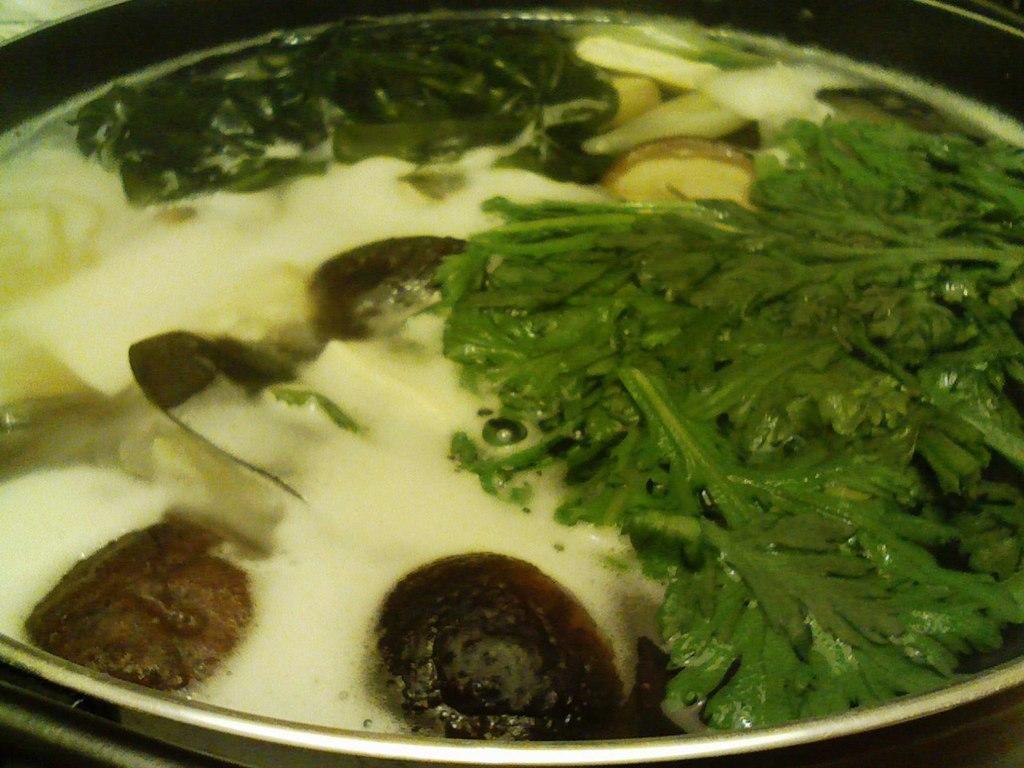Can you describe this image briefly? Here we can see vegetable leaves and food in container. 